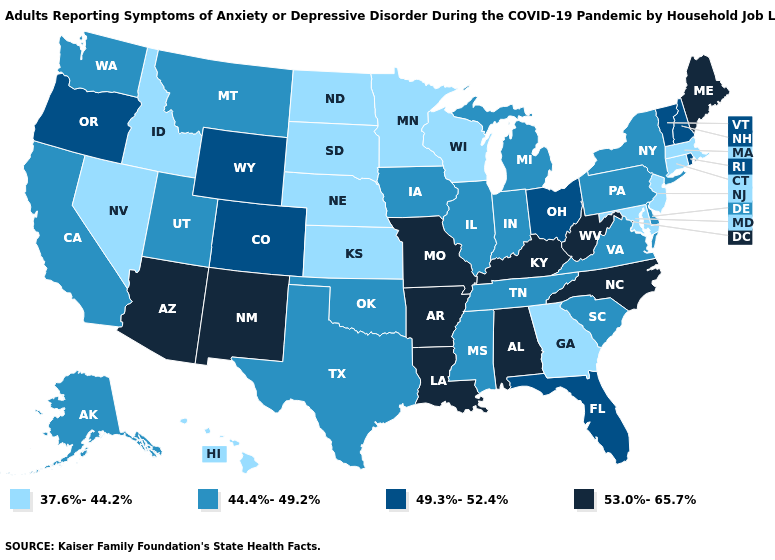Does the first symbol in the legend represent the smallest category?
Give a very brief answer. Yes. Does Vermont have the same value as Ohio?
Be succinct. Yes. How many symbols are there in the legend?
Quick response, please. 4. Does the first symbol in the legend represent the smallest category?
Concise answer only. Yes. Does Michigan have the same value as Wyoming?
Write a very short answer. No. Which states have the lowest value in the West?
Give a very brief answer. Hawaii, Idaho, Nevada. Name the states that have a value in the range 44.4%-49.2%?
Quick response, please. Alaska, California, Delaware, Illinois, Indiana, Iowa, Michigan, Mississippi, Montana, New York, Oklahoma, Pennsylvania, South Carolina, Tennessee, Texas, Utah, Virginia, Washington. Does the map have missing data?
Concise answer only. No. Does the map have missing data?
Be succinct. No. Which states hav the highest value in the South?
Answer briefly. Alabama, Arkansas, Kentucky, Louisiana, North Carolina, West Virginia. What is the value of Alaska?
Write a very short answer. 44.4%-49.2%. Name the states that have a value in the range 44.4%-49.2%?
Answer briefly. Alaska, California, Delaware, Illinois, Indiana, Iowa, Michigan, Mississippi, Montana, New York, Oklahoma, Pennsylvania, South Carolina, Tennessee, Texas, Utah, Virginia, Washington. What is the lowest value in the USA?
Short answer required. 37.6%-44.2%. Does Maine have a higher value than Utah?
Be succinct. Yes. 